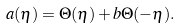<formula> <loc_0><loc_0><loc_500><loc_500>a ( \eta ) = \Theta ( \eta ) + b \Theta ( - \eta ) .</formula> 